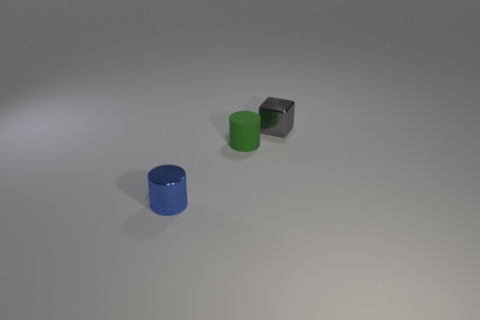Add 3 small matte spheres. How many objects exist? 6 Subtract all blue cylinders. How many cylinders are left? 1 Subtract 1 cylinders. How many cylinders are left? 1 Subtract all cylinders. How many objects are left? 1 Subtract all small blue cylinders. Subtract all blue objects. How many objects are left? 1 Add 3 matte cylinders. How many matte cylinders are left? 4 Add 1 brown balls. How many brown balls exist? 1 Subtract 1 gray cubes. How many objects are left? 2 Subtract all cyan cylinders. Subtract all brown balls. How many cylinders are left? 2 Subtract all brown cubes. How many green cylinders are left? 1 